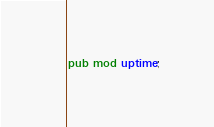Convert code to text. <code><loc_0><loc_0><loc_500><loc_500><_Rust_>pub mod uptime;
</code> 